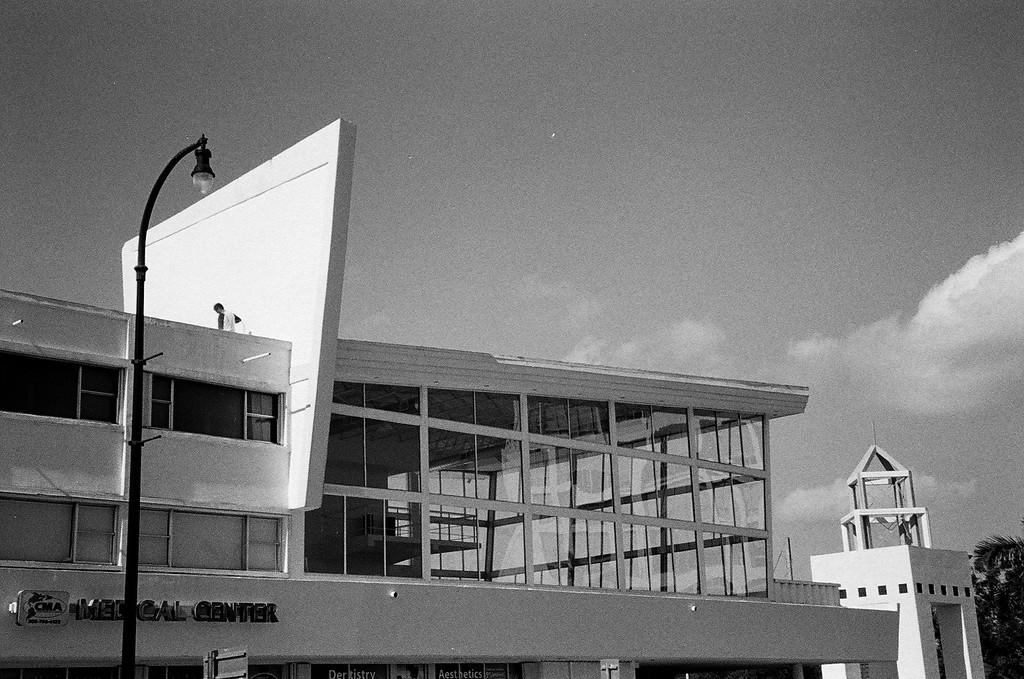What type of structure is in the image? There is a building in the image. What is located in front of the building? There is a street light pole in front of the building. Where can a tree be found in the image? There is a tree in the bottom right corner of the image. What is visible at the top of the image? The sky is visible at the top of the image. How many brothers are standing next to the tree in the image? There are no people, including brothers, present in the image. 